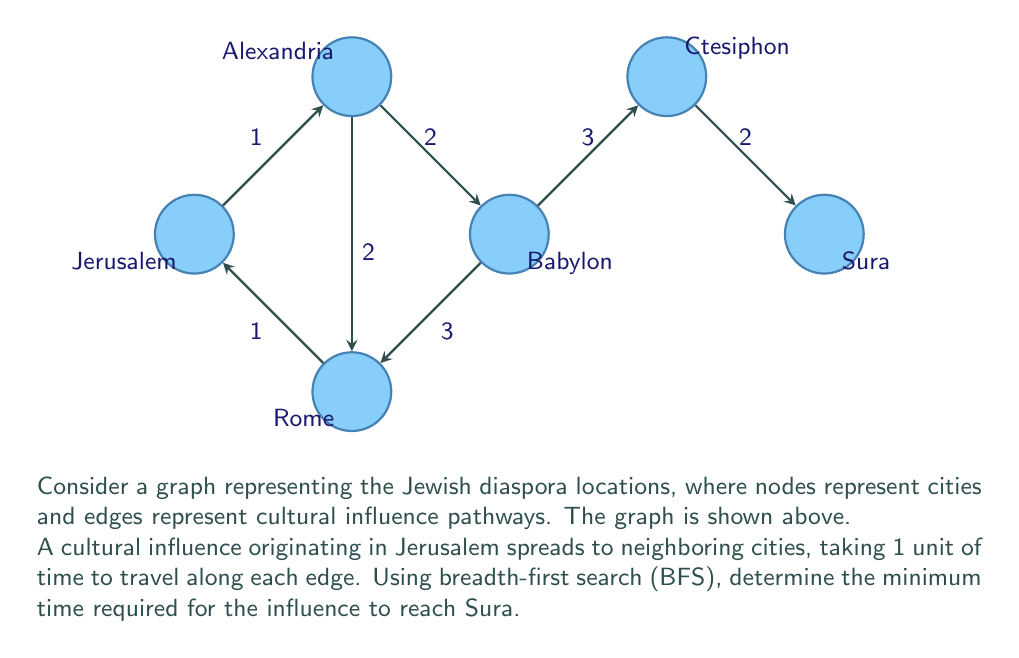Can you answer this question? To solve this problem, we'll use a breadth-first search (BFS) algorithm to find the shortest path from Jerusalem to Sura. We'll proceed step-by-step:

1) Initialize:
   - Queue: [Jerusalem]
   - Visited: {Jerusalem}
   - Distance: {Jerusalem: 0}

2) BFS iterations:
   a) Dequeue Jerusalem:
      - Add neighbors to queue: Alexandria, Rome
      - Update distances: Alexandria (1), Rome (1)
      - Queue: [Alexandria, Rome]
      - Visited: {Jerusalem, Alexandria, Rome}

   b) Dequeue Alexandria:
      - Add neighbor to queue: Babylon
      - Update distance: Babylon (3)
      - Queue: [Rome, Babylon]
      - Visited: {Jerusalem, Alexandria, Rome, Babylon}

   c) Dequeue Rome:
      - No new unvisited neighbors
      - Queue: [Babylon]

   d) Dequeue Babylon:
      - Add neighbor to queue: Ctesiphon
      - Update distance: Ctesiphon (6)
      - Queue: [Ctesiphon]
      - Visited: {Jerusalem, Alexandria, Rome, Babylon, Ctesiphon}

   e) Dequeue Ctesiphon:
      - Add neighbor to queue: Sura
      - Update distance: Sura (8)
      - Queue: [Sura]
      - Visited: {Jerusalem, Alexandria, Rome, Babylon, Ctesiphon, Sura}

   f) Dequeue Sura:
      - Target reached, BFS ends

3) The shortest path is: Jerusalem -> Alexandria -> Babylon -> Ctesiphon -> Sura

4) The total time taken is the distance to Sura: 8 units

Therefore, the minimum time required for the cultural influence to reach Sura from Jerusalem is 8 units.
Answer: 8 units of time 